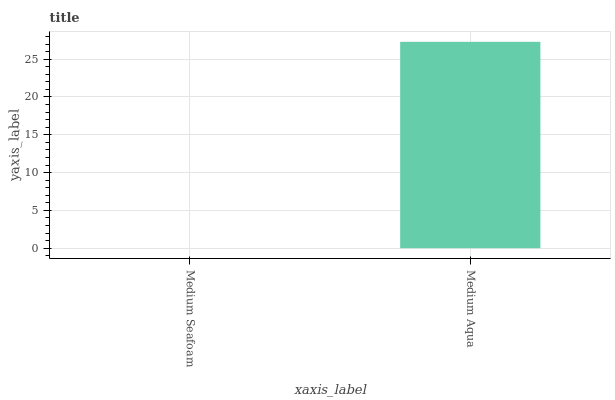Is Medium Seafoam the minimum?
Answer yes or no. Yes. Is Medium Aqua the maximum?
Answer yes or no. Yes. Is Medium Aqua the minimum?
Answer yes or no. No. Is Medium Aqua greater than Medium Seafoam?
Answer yes or no. Yes. Is Medium Seafoam less than Medium Aqua?
Answer yes or no. Yes. Is Medium Seafoam greater than Medium Aqua?
Answer yes or no. No. Is Medium Aqua less than Medium Seafoam?
Answer yes or no. No. Is Medium Aqua the high median?
Answer yes or no. Yes. Is Medium Seafoam the low median?
Answer yes or no. Yes. Is Medium Seafoam the high median?
Answer yes or no. No. Is Medium Aqua the low median?
Answer yes or no. No. 